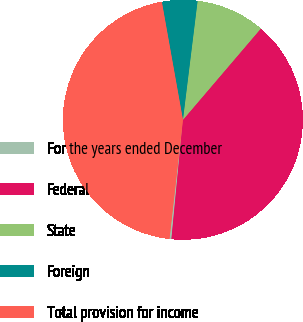<chart> <loc_0><loc_0><loc_500><loc_500><pie_chart><fcel>For the years ended December<fcel>Federal<fcel>State<fcel>Foreign<fcel>Total provision for income<nl><fcel>0.26%<fcel>40.29%<fcel>9.29%<fcel>4.77%<fcel>45.4%<nl></chart> 